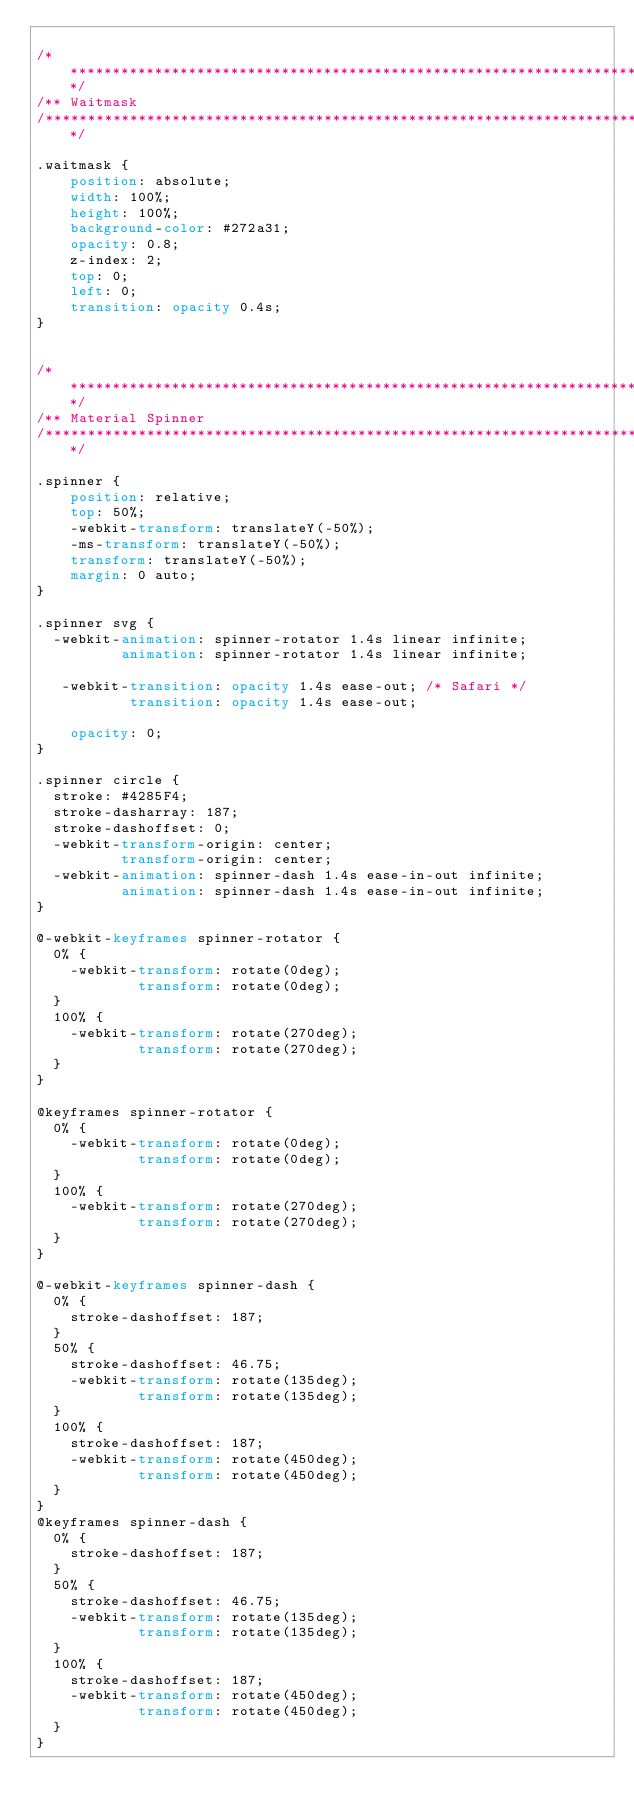<code> <loc_0><loc_0><loc_500><loc_500><_CSS_>
/**************************************************************************/
/** Waitmask
/**************************************************************************/

.waitmask {
    position: absolute;
    width: 100%;
    height: 100%;
    background-color: #272a31;
    opacity: 0.8;
    z-index: 2;
    top: 0;
    left: 0;
    transition: opacity 0.4s;
}


/**************************************************************************/
/** Material Spinner
/**************************************************************************/

.spinner {
    position: relative;
    top: 50%;
    -webkit-transform: translateY(-50%);
    -ms-transform: translateY(-50%);
    transform: translateY(-50%);
    margin: 0 auto;
}

.spinner svg {
  -webkit-animation: spinner-rotator 1.4s linear infinite;
          animation: spinner-rotator 1.4s linear infinite;

   -webkit-transition: opacity 1.4s ease-out; /* Safari */
           transition: opacity 1.4s ease-out;

    opacity: 0;
}

.spinner circle {
  stroke: #4285F4;
  stroke-dasharray: 187;
  stroke-dashoffset: 0;
  -webkit-transform-origin: center;
          transform-origin: center;
  -webkit-animation: spinner-dash 1.4s ease-in-out infinite;
          animation: spinner-dash 1.4s ease-in-out infinite;
}

@-webkit-keyframes spinner-rotator {
  0% {
    -webkit-transform: rotate(0deg);
            transform: rotate(0deg);
  }
  100% {
    -webkit-transform: rotate(270deg);
            transform: rotate(270deg);
  }
}

@keyframes spinner-rotator {
  0% {
    -webkit-transform: rotate(0deg);
            transform: rotate(0deg);
  }
  100% {
    -webkit-transform: rotate(270deg);
            transform: rotate(270deg);
  }
}

@-webkit-keyframes spinner-dash {
  0% {
    stroke-dashoffset: 187;
  }
  50% {
    stroke-dashoffset: 46.75;
    -webkit-transform: rotate(135deg);
            transform: rotate(135deg);
  }
  100% {
    stroke-dashoffset: 187;
    -webkit-transform: rotate(450deg);
            transform: rotate(450deg);
  }
}
@keyframes spinner-dash {
  0% {
    stroke-dashoffset: 187;
  }
  50% {
    stroke-dashoffset: 46.75;
    -webkit-transform: rotate(135deg);
            transform: rotate(135deg);
  }
  100% {
    stroke-dashoffset: 187;
    -webkit-transform: rotate(450deg);
            transform: rotate(450deg);
  }
}


</code> 